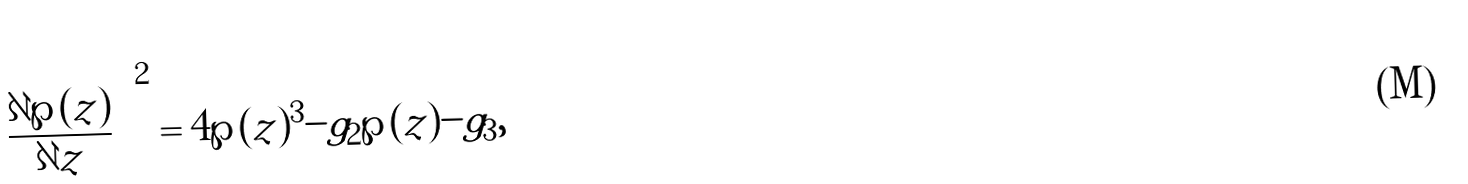<formula> <loc_0><loc_0><loc_500><loc_500>\left ( \frac { \partial \wp ( z ) } { \partial z } \right ) ^ { 2 } = 4 \wp ( z ) ^ { 3 } - g _ { 2 } \wp ( z ) - g _ { 3 } ,</formula> 